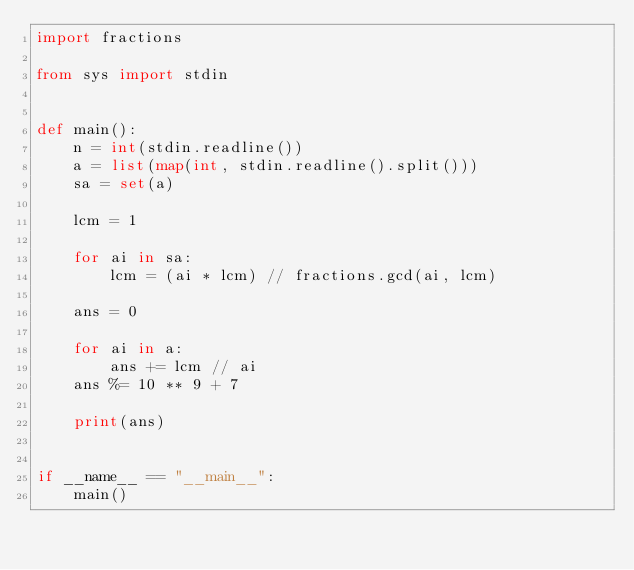Convert code to text. <code><loc_0><loc_0><loc_500><loc_500><_Python_>import fractions

from sys import stdin


def main():
    n = int(stdin.readline())
    a = list(map(int, stdin.readline().split()))
    sa = set(a)

    lcm = 1

    for ai in sa:
        lcm = (ai * lcm) // fractions.gcd(ai, lcm)

    ans = 0

    for ai in a:
        ans += lcm // ai
    ans %= 10 ** 9 + 7

    print(ans)


if __name__ == "__main__":
    main()
</code> 